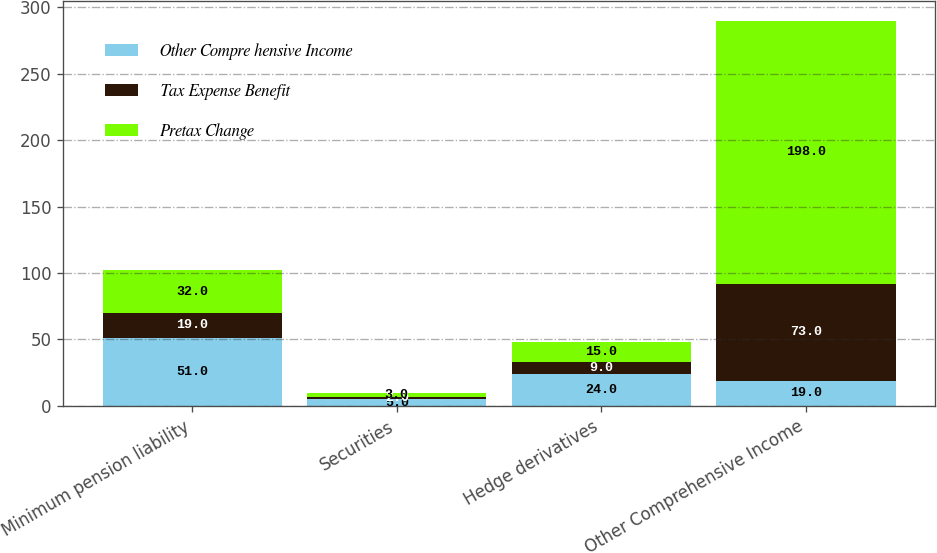Convert chart to OTSL. <chart><loc_0><loc_0><loc_500><loc_500><stacked_bar_chart><ecel><fcel>Minimum pension liability<fcel>Securities<fcel>Hedge derivatives<fcel>Other Comprehensive Income<nl><fcel>Other Compre hensive Income<fcel>51<fcel>5<fcel>24<fcel>19<nl><fcel>Tax Expense Benefit<fcel>19<fcel>2<fcel>9<fcel>73<nl><fcel>Pretax Change<fcel>32<fcel>3<fcel>15<fcel>198<nl></chart> 